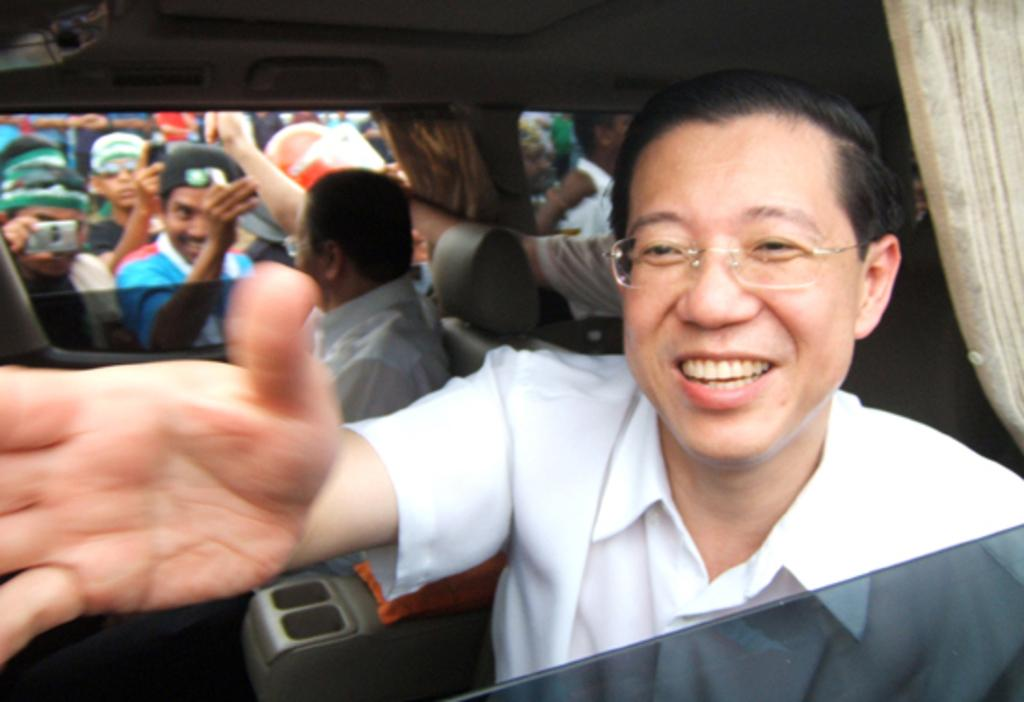How many people are inside the car in the image? There are three people sitting inside the car. What are the people at the back side of the car doing? These people are taking pictures. Can you describe the activity of the people inside the car? The people inside the car are likely passengers, as they are sitting. What is the opinion of the metal point in the image? There is no mention of a metal point in the image, so it is not possible to determine its opinion. 